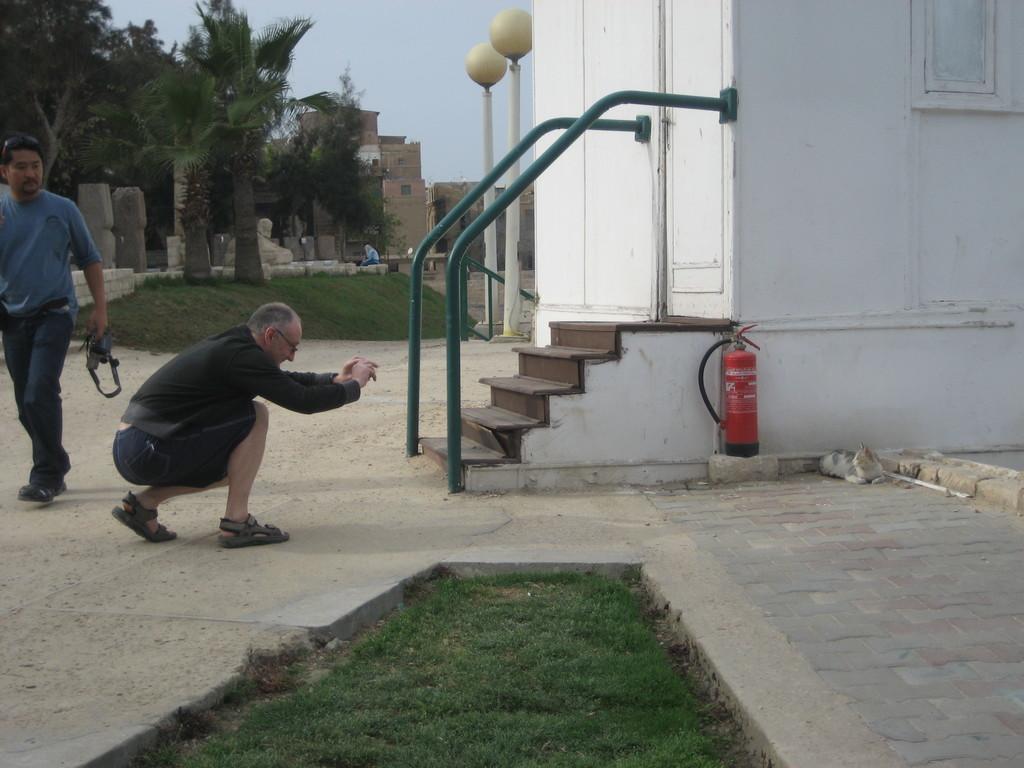Could you give a brief overview of what you see in this image? In this picture there is a man sitting and holding the object and there is a man holding the object and he is walking. At the back there are buildings and trees and there are street lights and there is a person sitting on the wall. In the foreground there is a fire hydrant and there is a stair case and there is a cat on the floor. At the top there is sky. At the bottom there is grass and there is ground. 